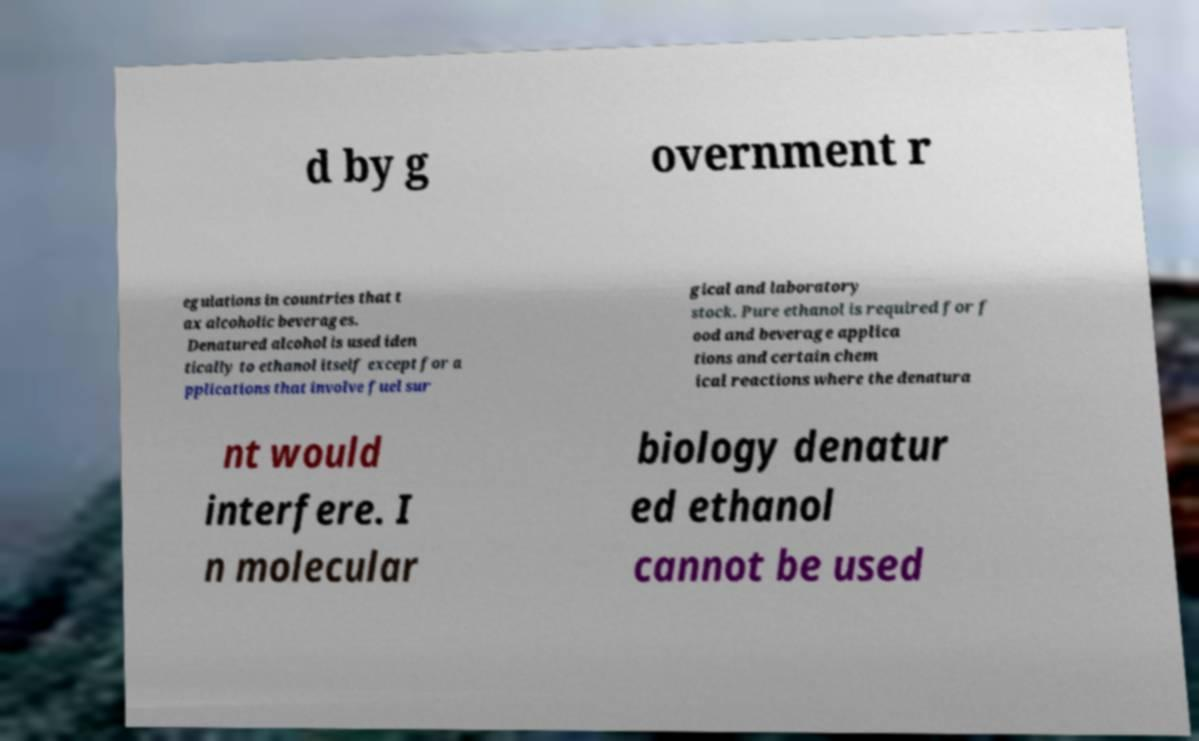Please identify and transcribe the text found in this image. d by g overnment r egulations in countries that t ax alcoholic beverages. Denatured alcohol is used iden tically to ethanol itself except for a pplications that involve fuel sur gical and laboratory stock. Pure ethanol is required for f ood and beverage applica tions and certain chem ical reactions where the denatura nt would interfere. I n molecular biology denatur ed ethanol cannot be used 